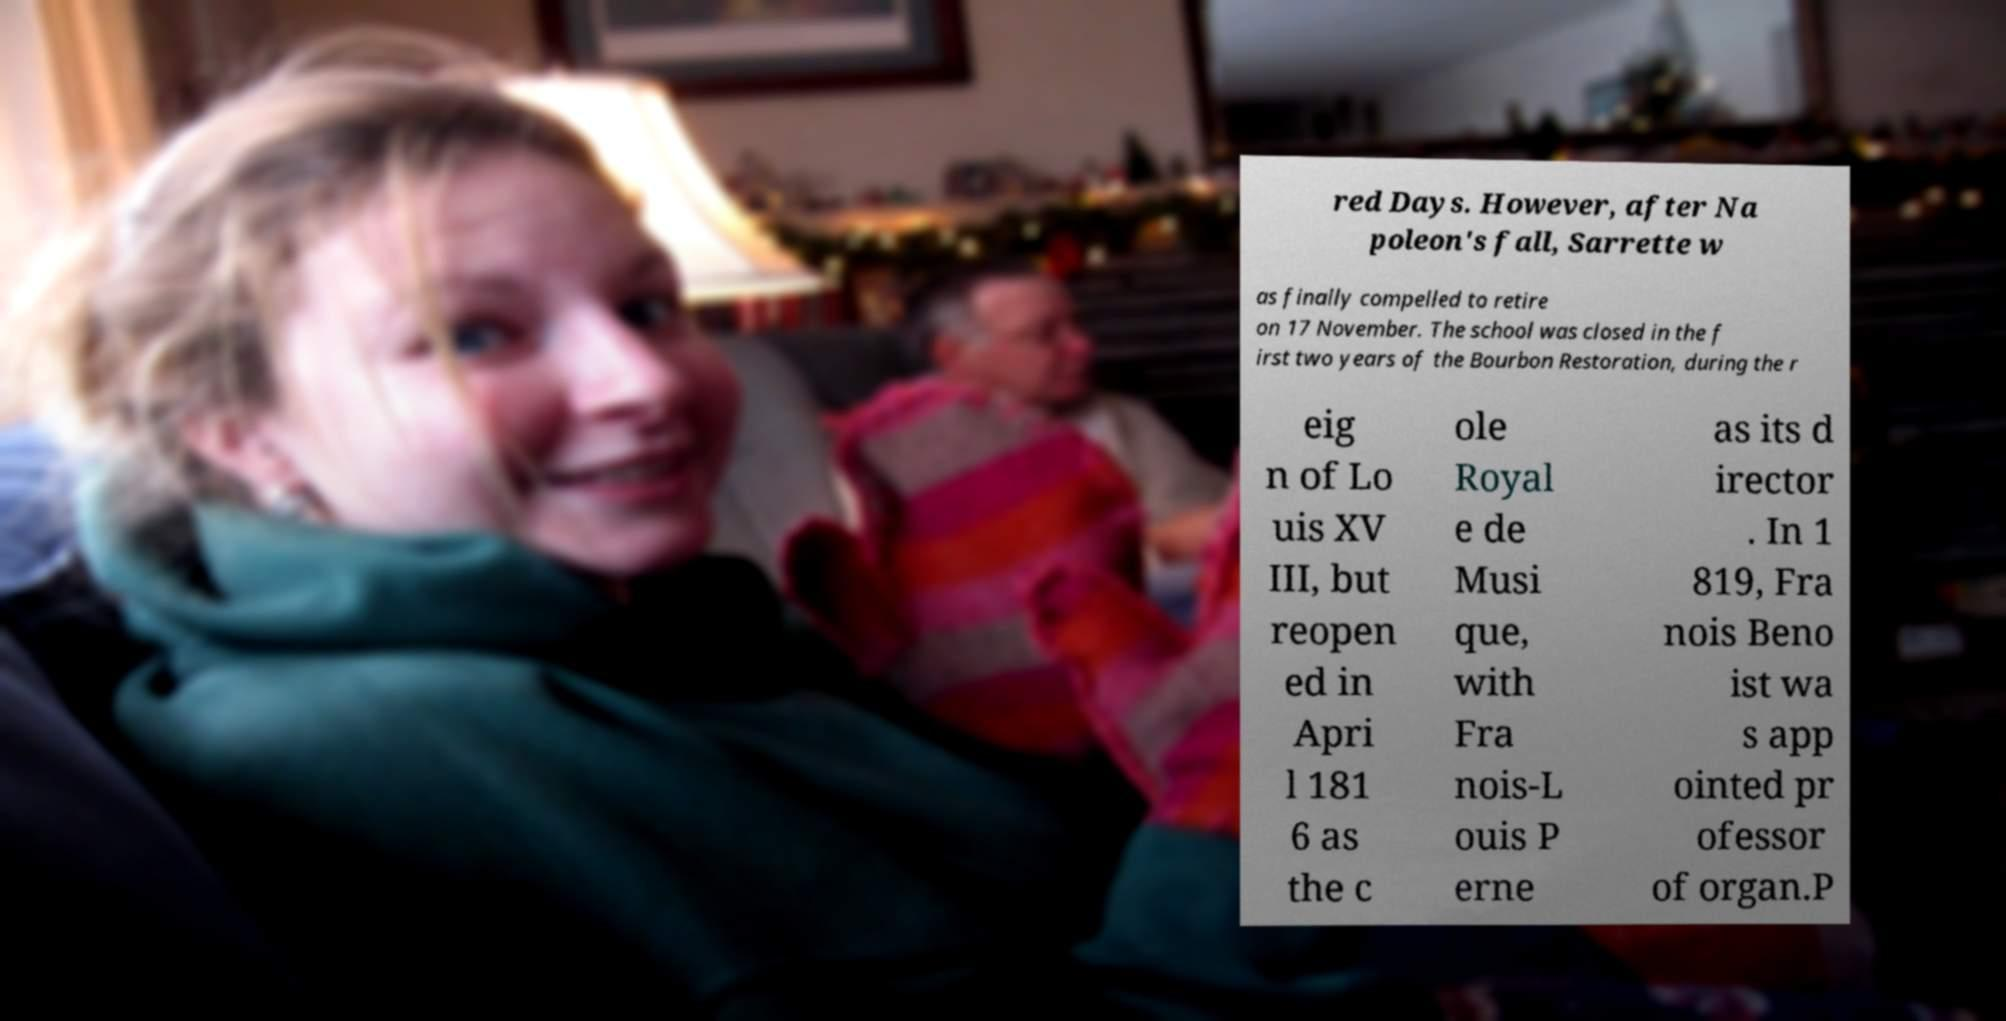What messages or text are displayed in this image? I need them in a readable, typed format. red Days. However, after Na poleon's fall, Sarrette w as finally compelled to retire on 17 November. The school was closed in the f irst two years of the Bourbon Restoration, during the r eig n of Lo uis XV III, but reopen ed in Apri l 181 6 as the c ole Royal e de Musi que, with Fra nois-L ouis P erne as its d irector . In 1 819, Fra nois Beno ist wa s app ointed pr ofessor of organ.P 